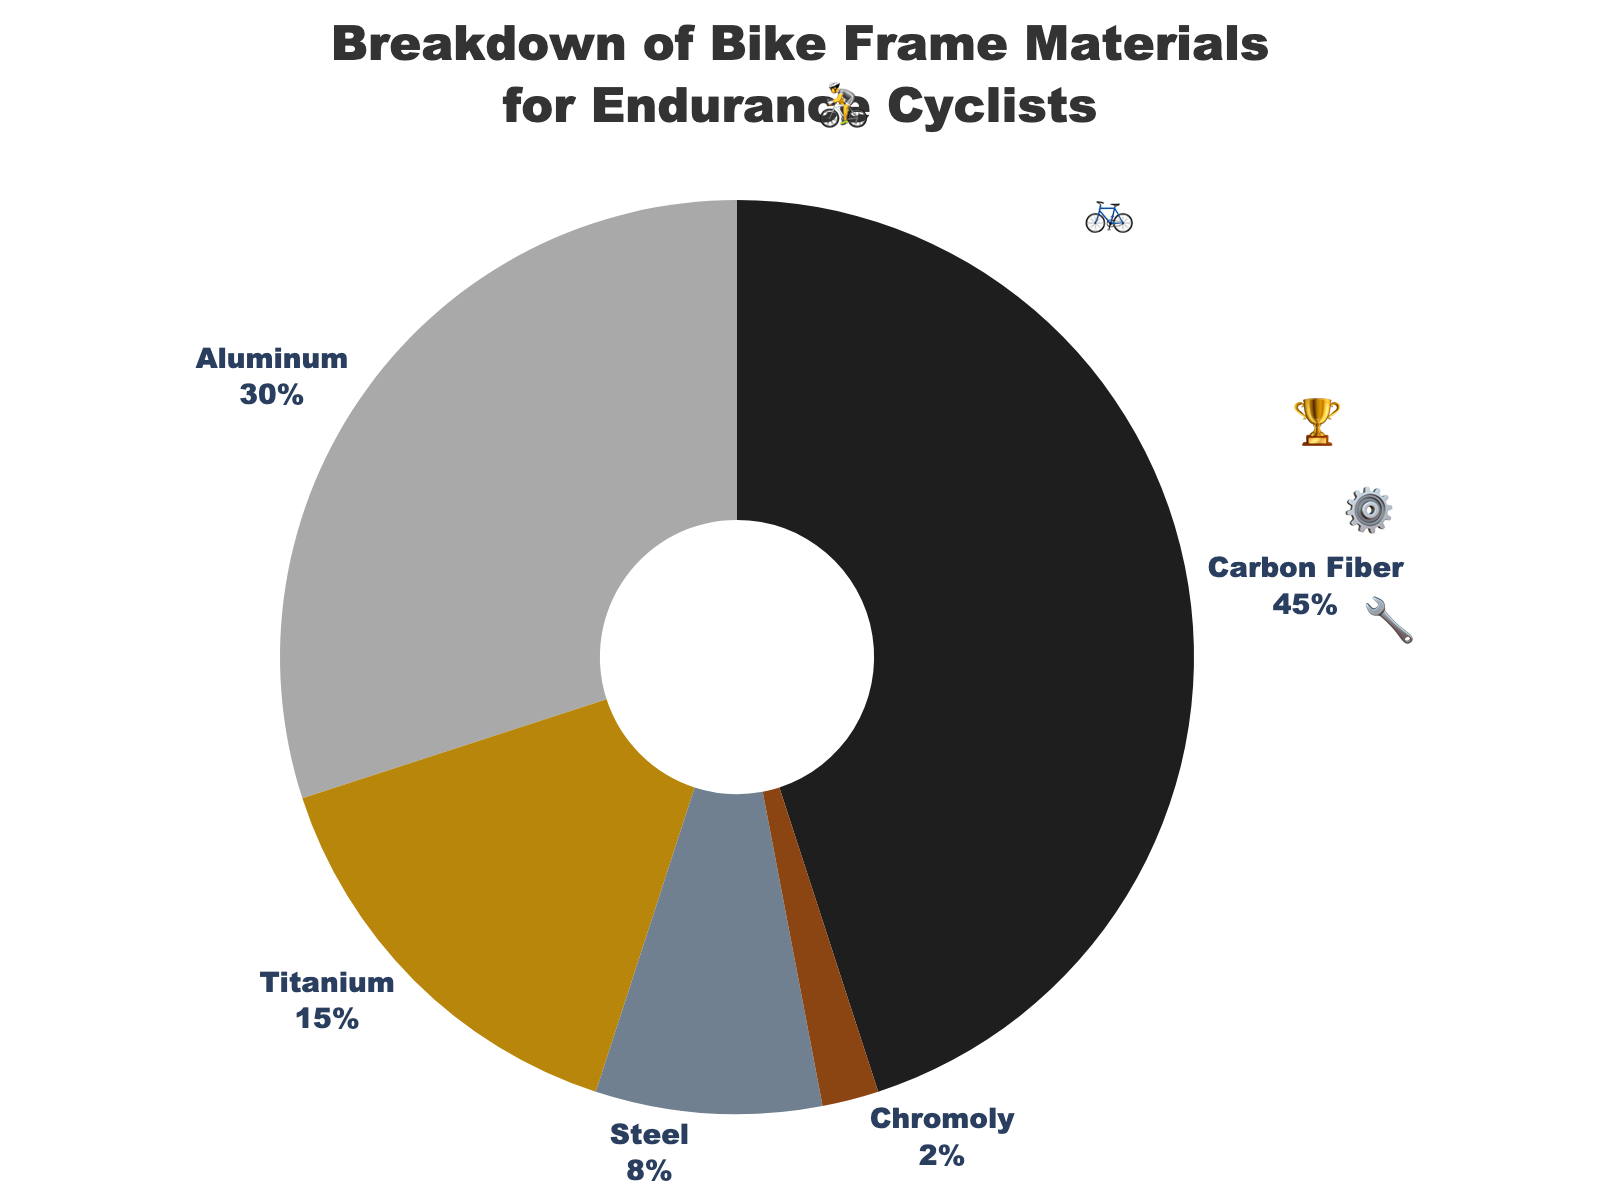Which material makes up the largest percentage of bike frames for endurance cyclists? The material with the largest percentage is represented by the biggest slice in the pie chart, which is labeled 45%.
Answer: Carbon Fiber What percentage of bike frames are made of Titanium and Steel combined? Adding the percentages for Titanium (15%) and Steel (8%) gives 15% + 8%.
Answer: 23% Is Aluminum more popular than Steel for bike frames? Comparing the percentages for Aluminum (30%) and Steel (8%), Aluminum has a higher percentage.
Answer: Yes What is the difference in percentage between the most and least common bike frame materials? The most common material is Carbon Fiber (45%) and the least common is Chromoly (2%). Subtracting the percentages gives 45% - 2%.
Answer: 43% If you had 100 endurance cyclists, how many of them would likely ride a bike with a Carbon Fiber frame? Using the percentage for Carbon Fiber (45%), multiplying 100 by 0.45 gives the number of cyclists.
Answer: 45 Which material is represented by the emoji '🏆'? The emoji '🏆' is used for Titanium in the chart.
Answer: Titanium Considering all materials, which one has nearly twice the percentage of Chromoly? Chromoly is at 2%, so nearly twice would be 4%. The closest material above this value is Steel with 8%.
Answer: Steel How many materials have a percentage greater than 10%? Looking at the percentages, three materials (Carbon Fiber - 45%, Aluminum - 30%, Titanium - 15%) have more than 10%.
Answer: 3 Is Steel less popular than Titanium for bike frames? Comparing the percentages for Steel (8%) and Titanium (15%), Steel has a lower percentage.
Answer: Yes What is the combined percentage of bike frames made from materials other than Carbon Fiber? Subtracting the percentage of Carbon Fiber (45%) from 100% gives 100% - 45%.
Answer: 55% 